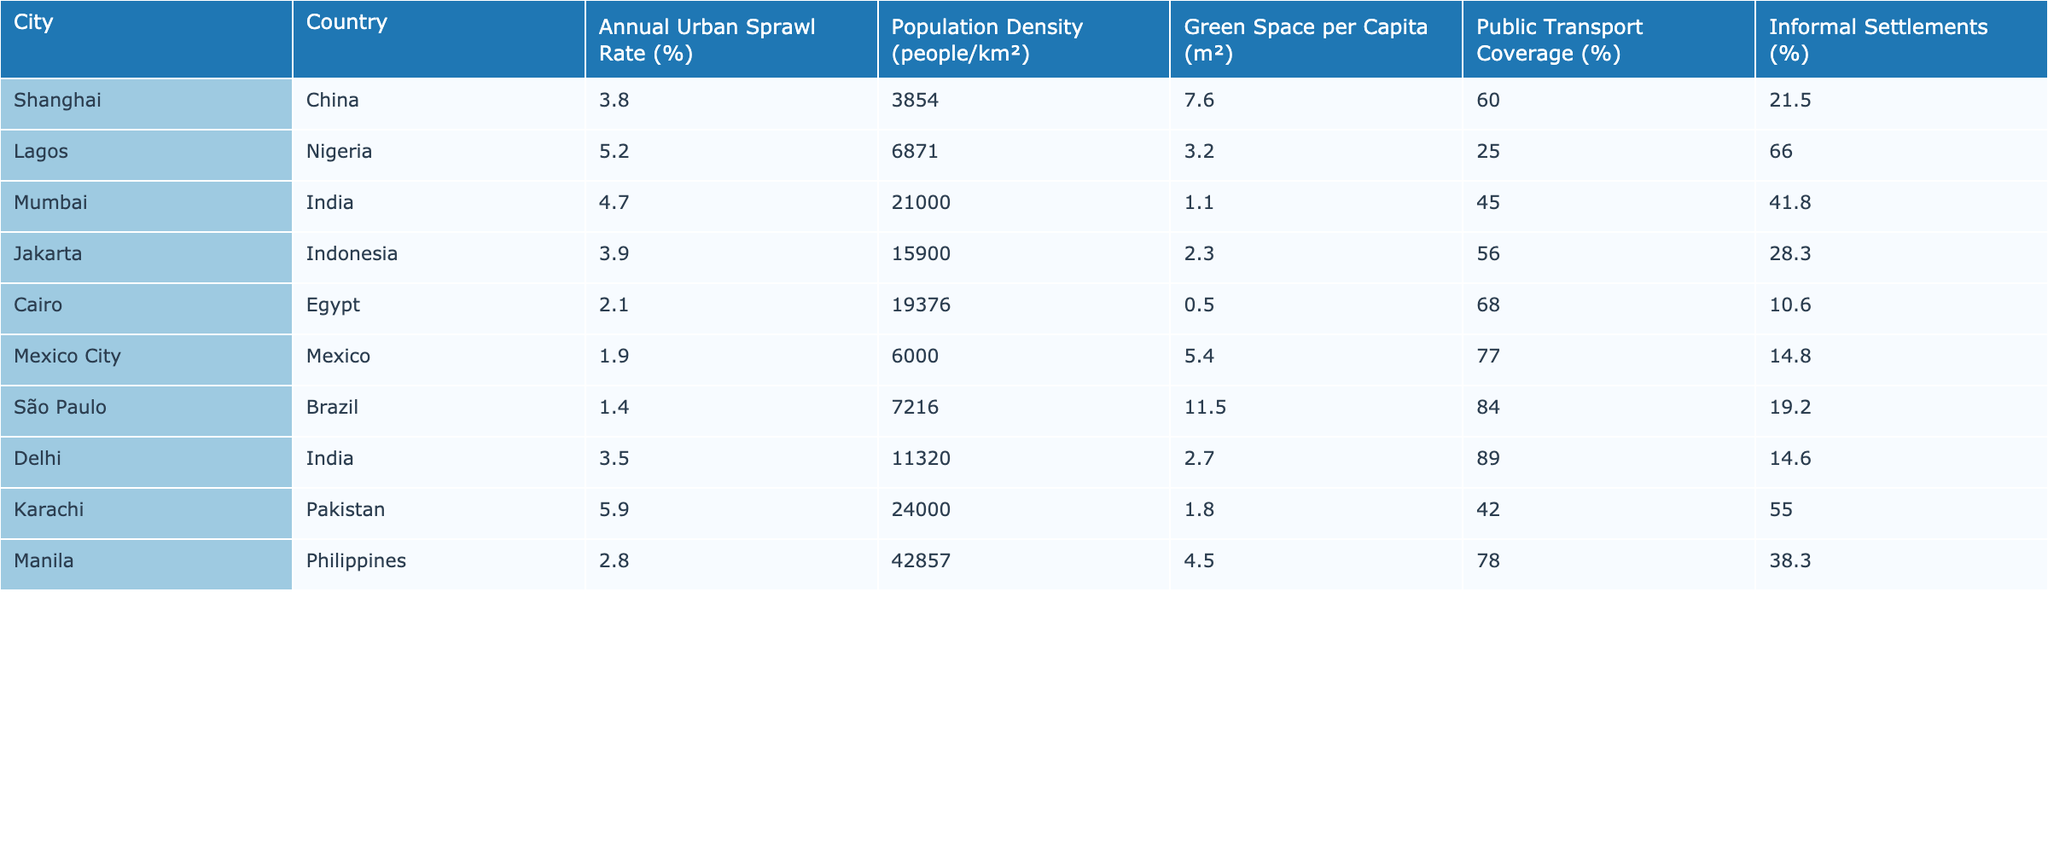What is the annual urban sprawl rate of Lagos? The table shows Lagos with an annual urban sprawl rate of 5.2%.
Answer: 5.2% Which city has the highest population density? The highest population density is found in Manila, with 42857 people/km².
Answer: 42857 What percentage of the population lives in informal settlements in Cairo? Cairo has 10.6% of its population living in informal settlements as per the table data.
Answer: 10.6% What is the average public transport coverage for these cities? To find the average, sum the public transport coverage percentages: 60 + 25 + 45 + 56 + 68 + 77 + 84 + 89 + 42 + 78 =  584. Divide by the number of cities (10) to get 584/10 = 58.4%.
Answer: 58.4% Is the green space per capita in São Paulo greater than in Mexico City? São Paulo has 11.5 m² while Mexico City has 5.4 m², confirming that São Paulo has more green space per capita.
Answer: Yes What is the difference in annual urban sprawl rates between Karachi and São Paulo? Karachi's sprawl rate is 5.9%, and São Paulo's rate is 1.4%. The difference is 5.9 - 1.4 = 4.5%.
Answer: 4.5% Which city has the lowest green space per capita and what is that amount? The lowest green space per capita is in Mumbai at 1.1 m².
Answer: 1.1 m² What is the total percentage of population living in informal settlements for all cities combined? The total is calculated as follows: 21.5 + 66.0 + 41.8 + 28.3 + 10.6 + 14.8 + 19.2 + 14.6 + 55.0 + 38.3 =  340.8%.
Answer: 340.8% Which city shows the least public transport coverage between Lagos and Jakarta? Comparing the two, Lagos has 25% public transport coverage and Jakarta has 56%, which means Lagos has less.
Answer: Lagos Do more people per square kilometer live in Lagos than in Delhi? Lagos has a density of 6871 people/km², while Delhi has 11320 people/km², indicating that Delhi has a higher density.
Answer: No 